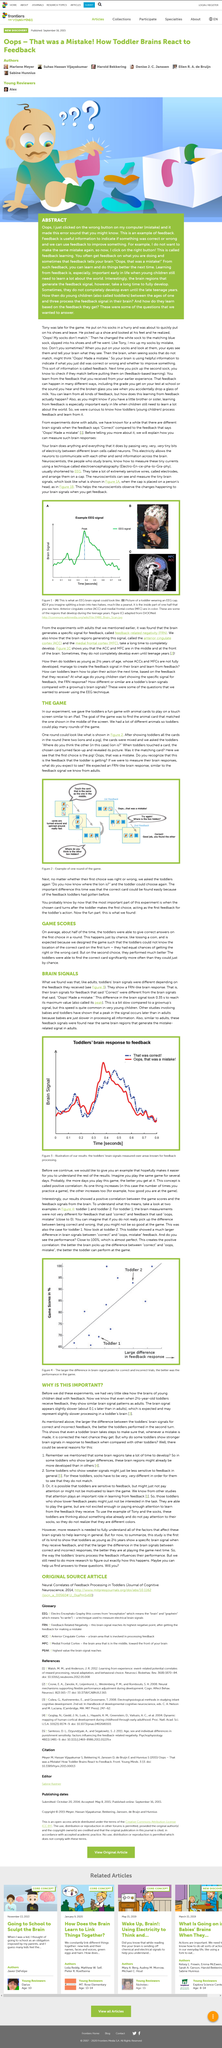Highlight a few significant elements in this photo. This article is about a game designed for toddlers. Research has found that when toddlers are given positive or negative feedback in response to their actions, the size of the difference between their brain signals for the correct and incorrect feedback predicts how well they will perform in their next turn. Toddlers' brains exhibit similar brain signal patterns to those of adults, thereby indicating a high degree of similarity between the two. Toddlers do not have faster brain responses than adults. The processing speed of a toddler's brain signals is approximately 0.1 second slower than that of an adult. 